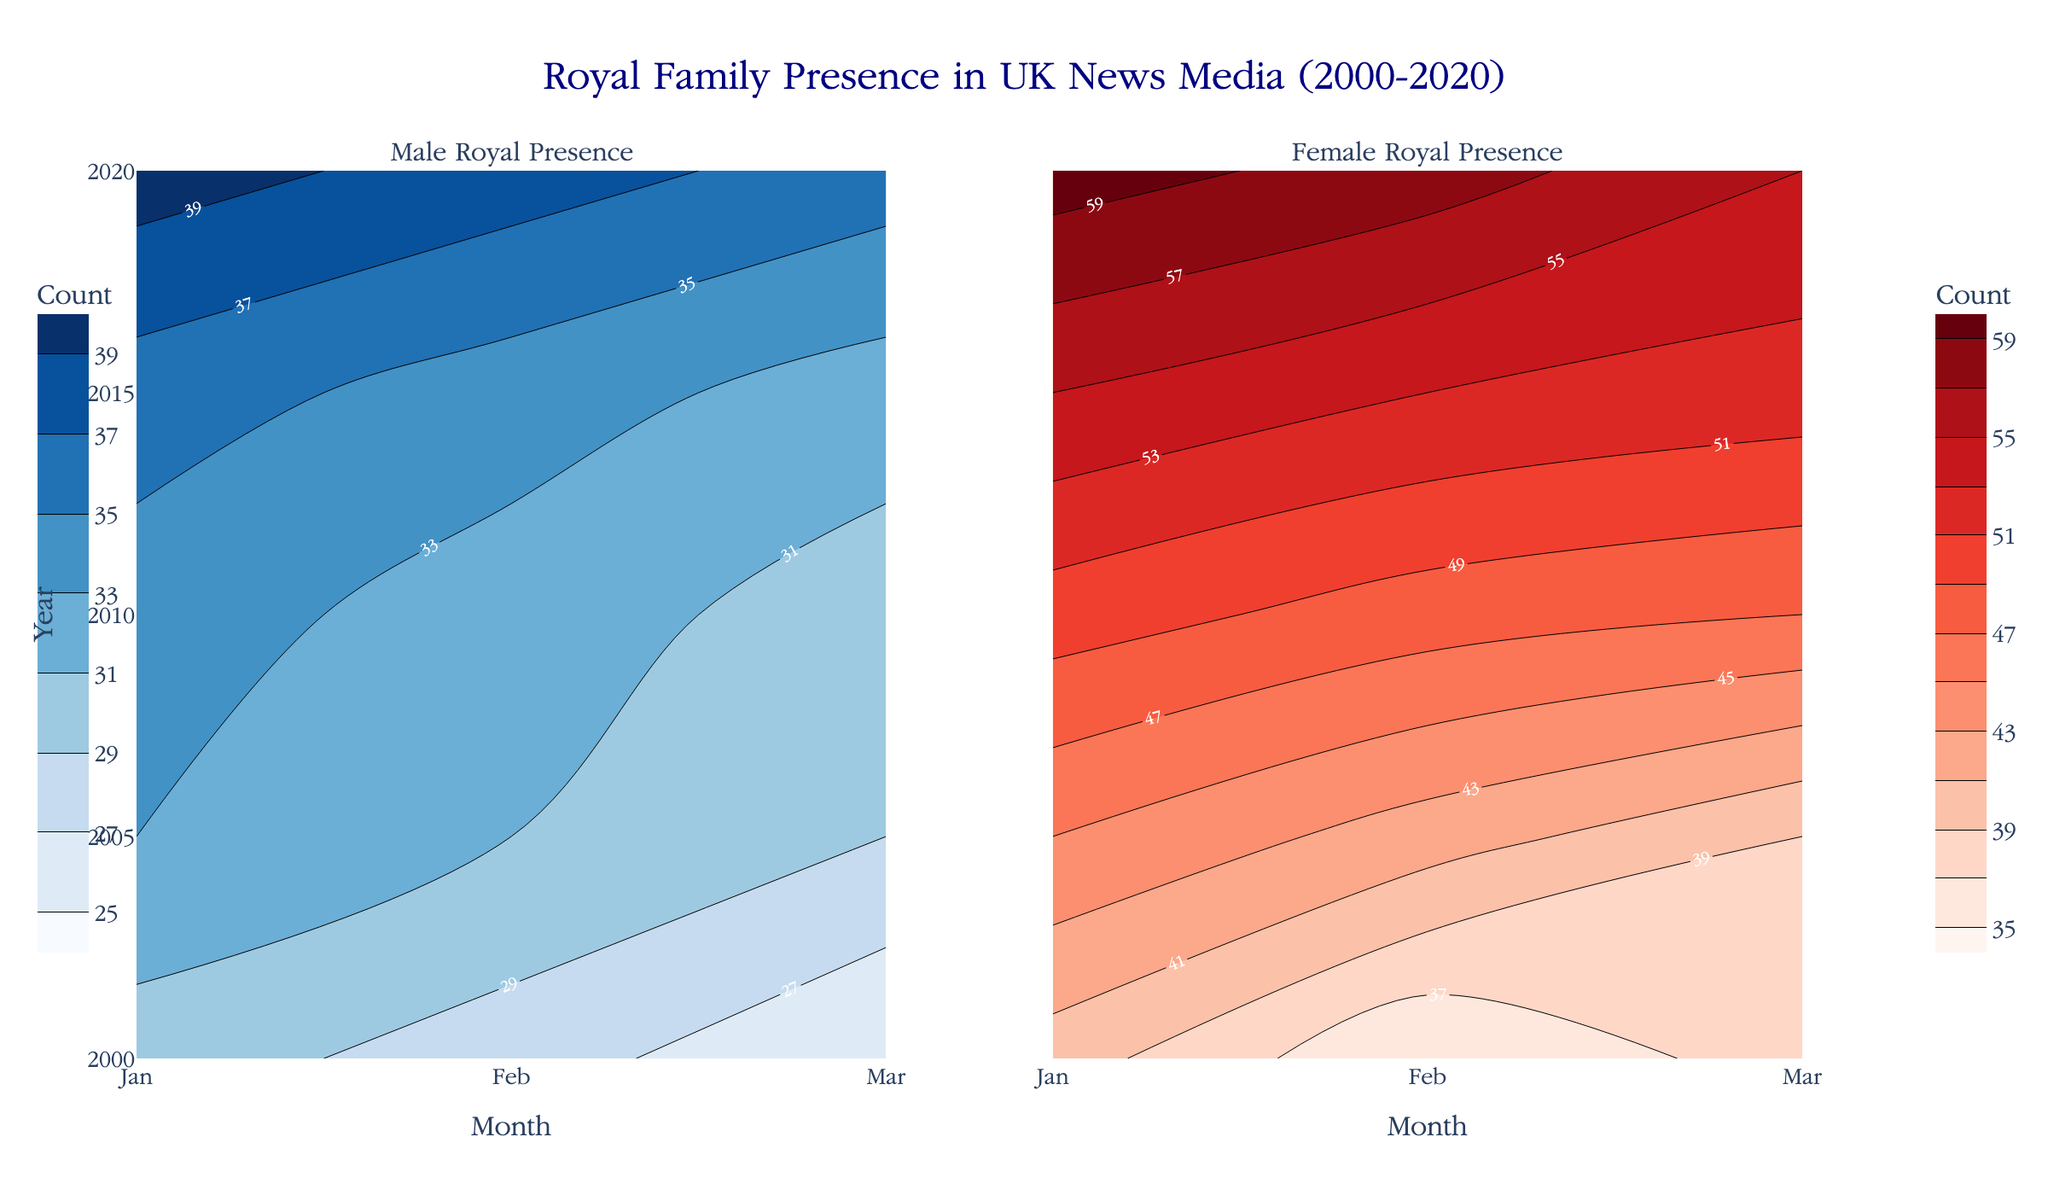What is the title of the figure? The title is located at the top center of the figure, so you can read it directly from there.
Answer: Royal Family Presence in UK News Media (2000-2020) What do the colors blue and red represent in this figure? The contour plots use colors to represent male and female royal presences, respectively. Blue tones represent male presence and red tones represent female presence.
Answer: Blue represents male presence, and red represents female presence In which year and month does the figure show the highest count of female royal presence in news media? Look at the red contour plot on the right side and find the point where the color is the darkest or the value is the highest.
Answer: 2020, January How does the male royal presence in February 2005 compare to that in February 2000? Look at the left contour plot, find the February positions for both years, and compare the counts from the contour lines at those points.
Answer: Higher in 2005 Which month sees the lowest male royal presence across all years? Look at the left contour plot (Male Royal Presence) and identify the month with consistently lighter colors or lower values.
Answer: March What is the difference in female royal presence between February 2015 and February 2020? Identify the values for February 2015 and February 2020 on the right contour plot and subtract the first from the latter.
Answer: 5 (58 - 53) Which gender has seen a steady rise in presence in the news media from 2000 to 2020? Compare the contours in both subplots from 2000 to 2020 and see which gender shows an upward trend in the color scales.
Answer: Female In which decade did male royal presence see the smallest change? Observe the male contour plot (left) and compare the color intensity over the decades to identify the smallest change.
Answer: 2000-2010 What is the average female royal presence in the month of January across all years shown? Sum up the female presence counts for January from the right contour plot for all years and divide by the number of years.
Answer: 48 How does the contour plot represent changes in royal presence over time? The contour lines in the plots indicate varying levels of royal presence; closer lines represent rapid changes, while further apart lines indicate slower changes.
Answer: Varying lines indicate changes in royal presence 